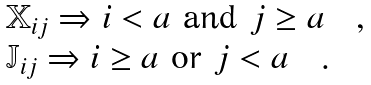Convert formula to latex. <formula><loc_0><loc_0><loc_500><loc_500>\begin{array} { l } { \mathbb { X } } _ { i j } \Rightarrow i < a \ \text {and} \ j \geq a \quad , \\ { \mathbb { J } } _ { i j } \Rightarrow i \geq a \ \text {or} \ j < a \quad . \end{array}</formula> 